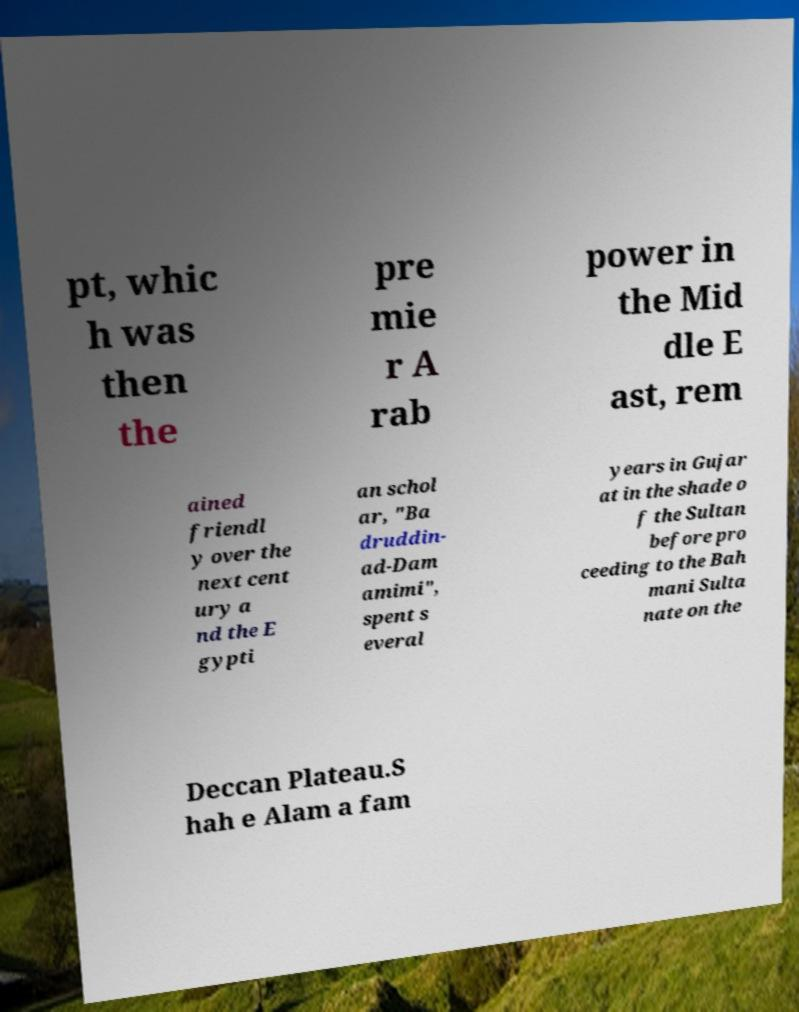What messages or text are displayed in this image? I need them in a readable, typed format. pt, whic h was then the pre mie r A rab power in the Mid dle E ast, rem ained friendl y over the next cent ury a nd the E gypti an schol ar, "Ba druddin- ad-Dam amimi", spent s everal years in Gujar at in the shade o f the Sultan before pro ceeding to the Bah mani Sulta nate on the Deccan Plateau.S hah e Alam a fam 